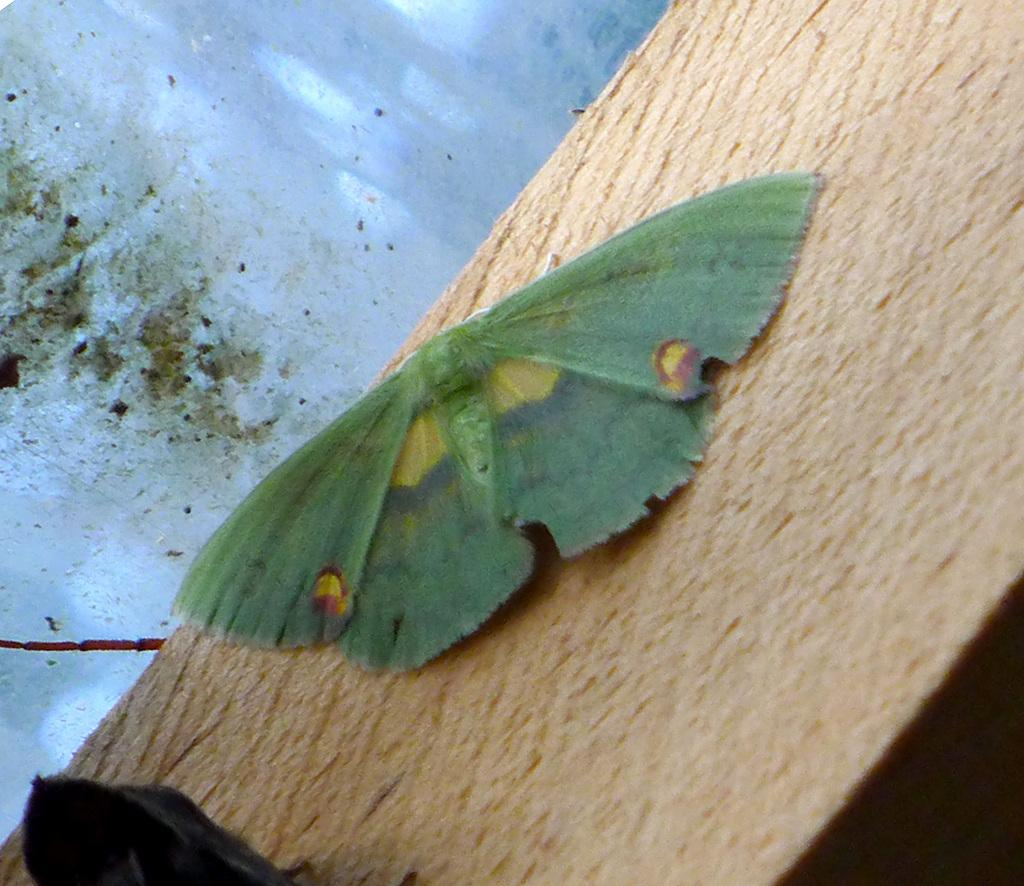What is on the wooden block in the image? There is a fly on a wooden block in the image. What can be seen in the background of the image? There is a wall in the background of the image. Can you describe the object at the bottom of the image? Unfortunately, the facts provided do not give any information about the object at the bottom of the image. How many trucks are parked in front of the houses in the image? There are no trucks or houses present in the image; it only features a fly on a wooden block and a wall in the background. 